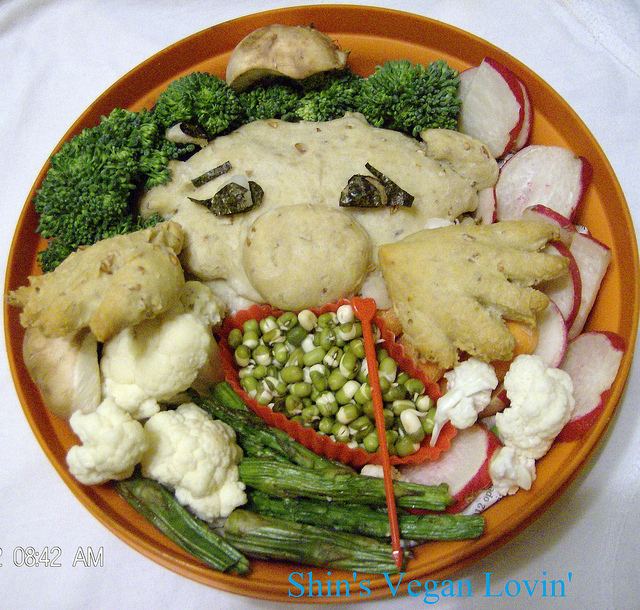Identify and read out the text in this image. Shin's Vegan Lovin' 08 42 AM 